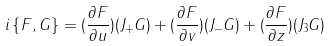<formula> <loc_0><loc_0><loc_500><loc_500>i \left \{ F , G \right \} = ( \frac { \partial F } { \partial u } ) ( J _ { + } G ) + ( \frac { \partial F } { \partial v } ) ( J _ { - } G ) + ( \frac { \partial F } { \partial z } ) ( J _ { 3 } G )</formula> 